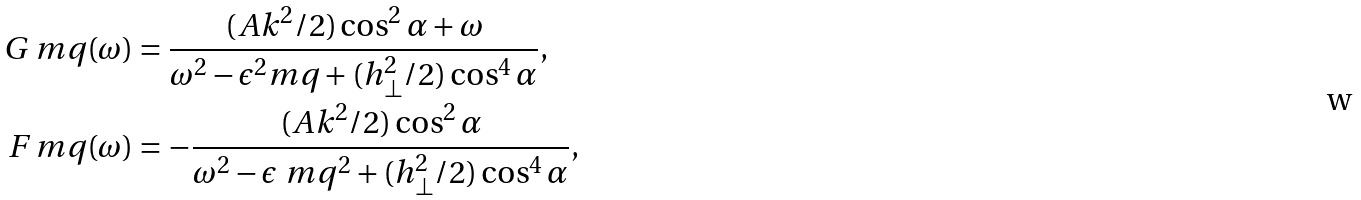Convert formula to latex. <formula><loc_0><loc_0><loc_500><loc_500>G _ { \ } m q ( \omega ) & = \frac { ( A k ^ { 2 } / 2 ) \cos ^ { 2 } \alpha + \omega } { \omega ^ { 2 } - \epsilon ^ { 2 } _ { \ } m q + ( h _ { \perp } ^ { 2 } / 2 ) \cos ^ { 4 } \alpha } , \\ F _ { \ } m q ( \omega ) & = - \frac { ( A k ^ { 2 } / 2 ) \cos ^ { 2 } \alpha } { \omega ^ { 2 } - \epsilon _ { \ } m q ^ { 2 } + ( h ^ { 2 } _ { \perp } / 2 ) \cos ^ { 4 } \alpha } ,</formula> 